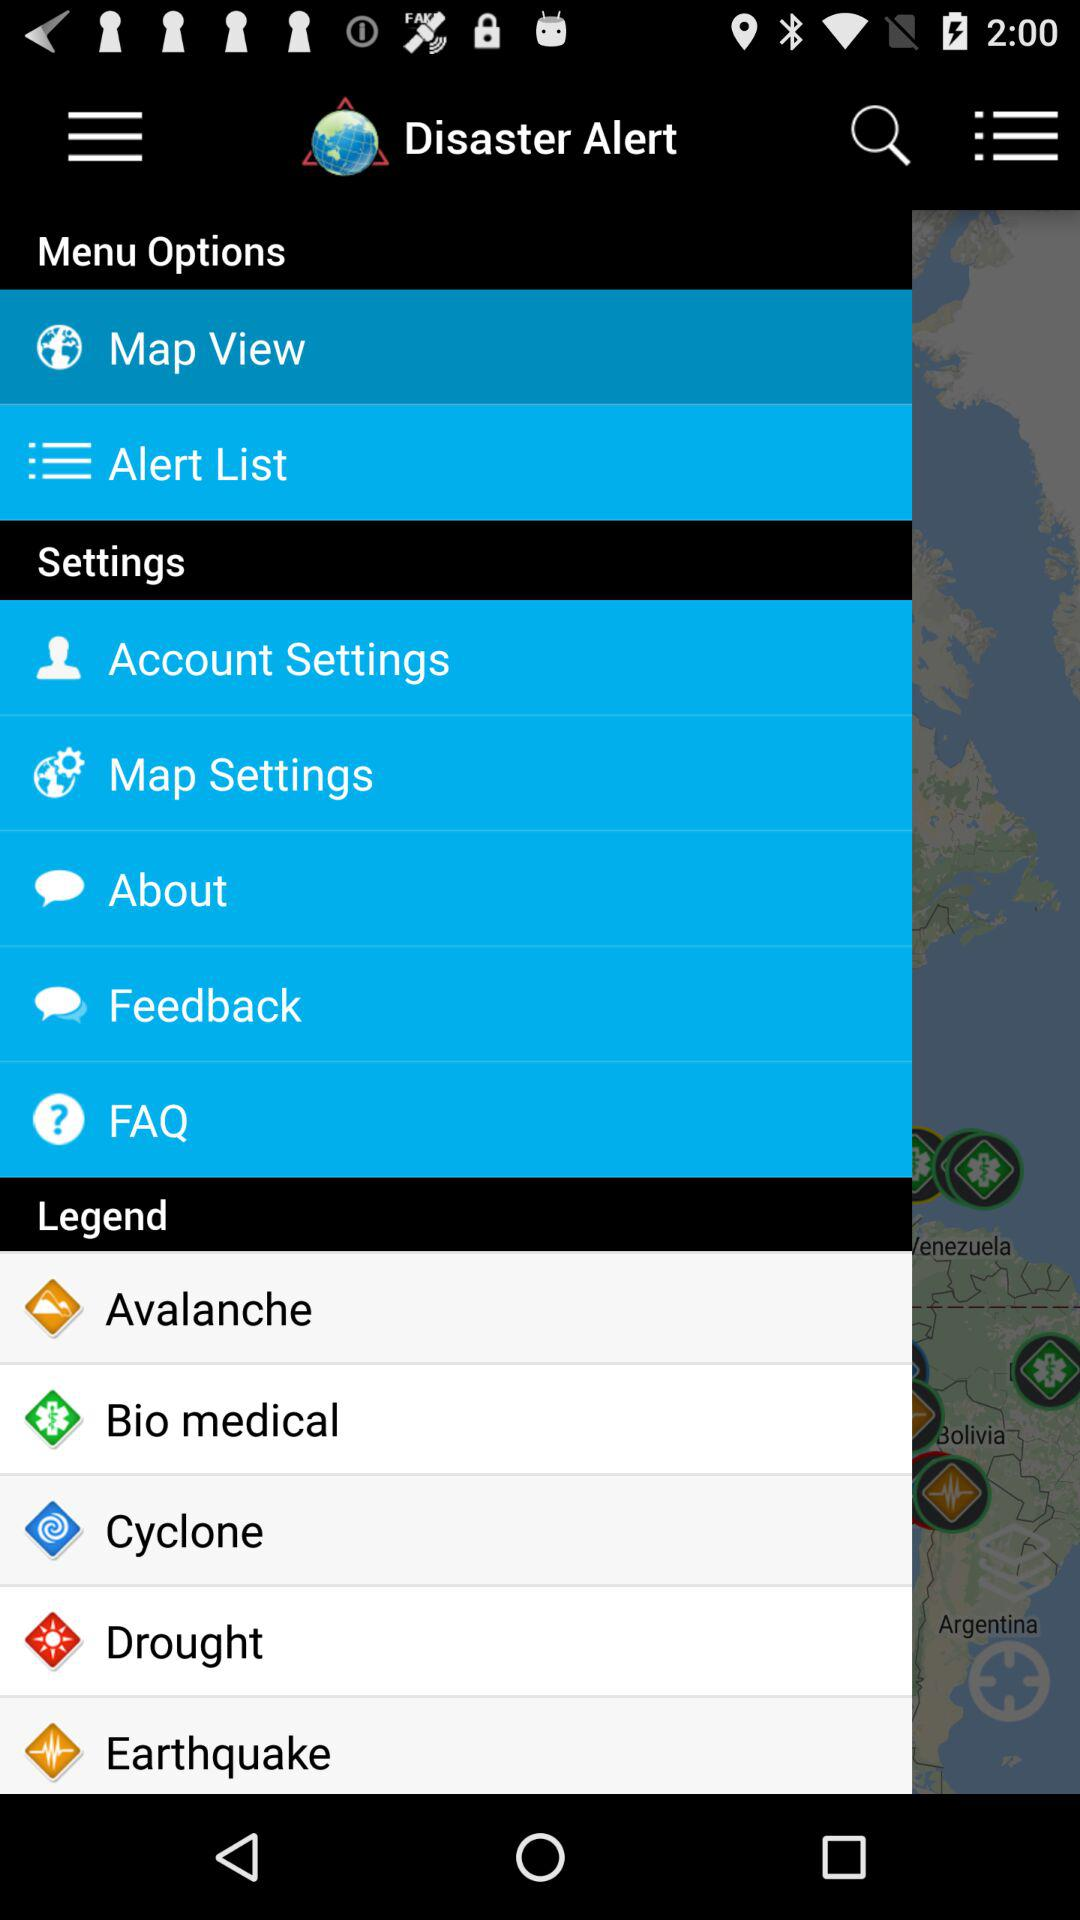What is the application name? The application name is "Disaster Alert". 